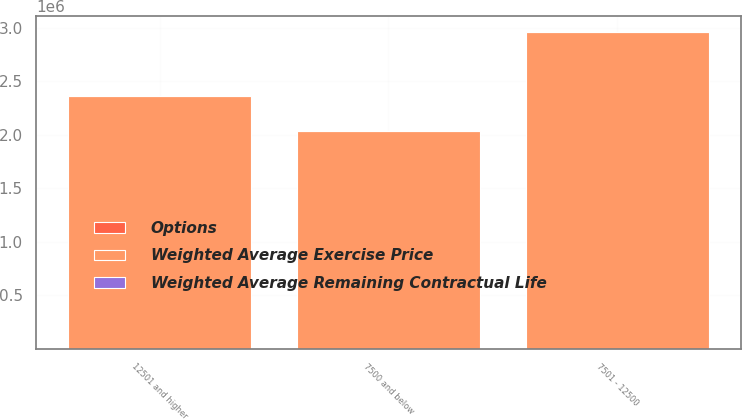<chart> <loc_0><loc_0><loc_500><loc_500><stacked_bar_chart><ecel><fcel>7500 and below<fcel>7501 - 12500<fcel>12501 and higher<nl><fcel>Weighted Average Exercise Price<fcel>2.03198e+06<fcel>2.96079e+06<fcel>2.35949e+06<nl><fcel>Options<fcel>2.2<fcel>6.73<fcel>9.43<nl><fcel>Weighted Average Remaining Contractual Life<fcel>62.36<fcel>105.54<fcel>148.4<nl></chart> 